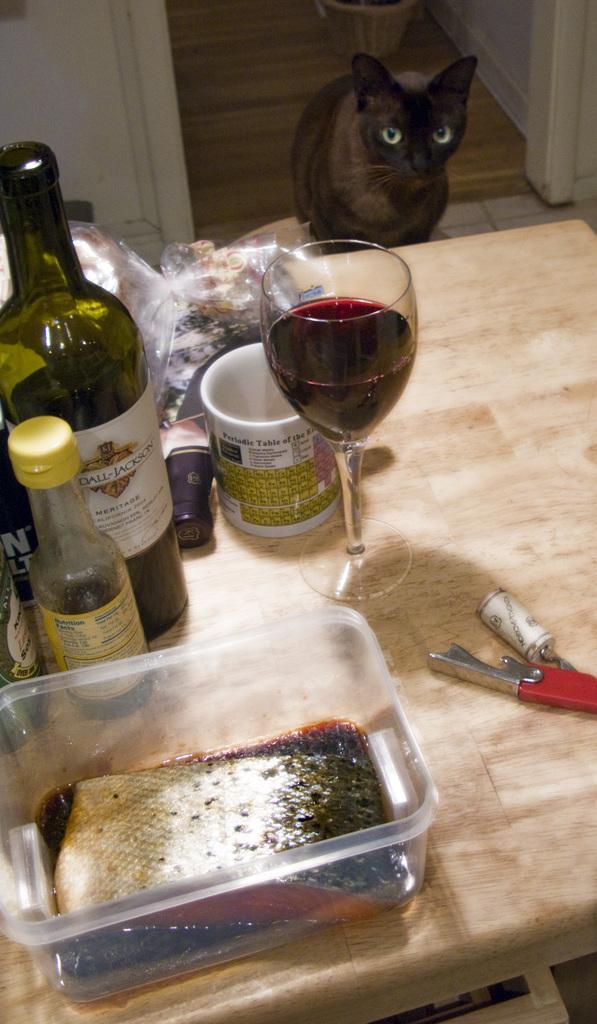Describe this image in one or two sentences. In the image we see there is a table on which there is a red wine glass and a bottle and plastic packet and on the ground there is a cat. 